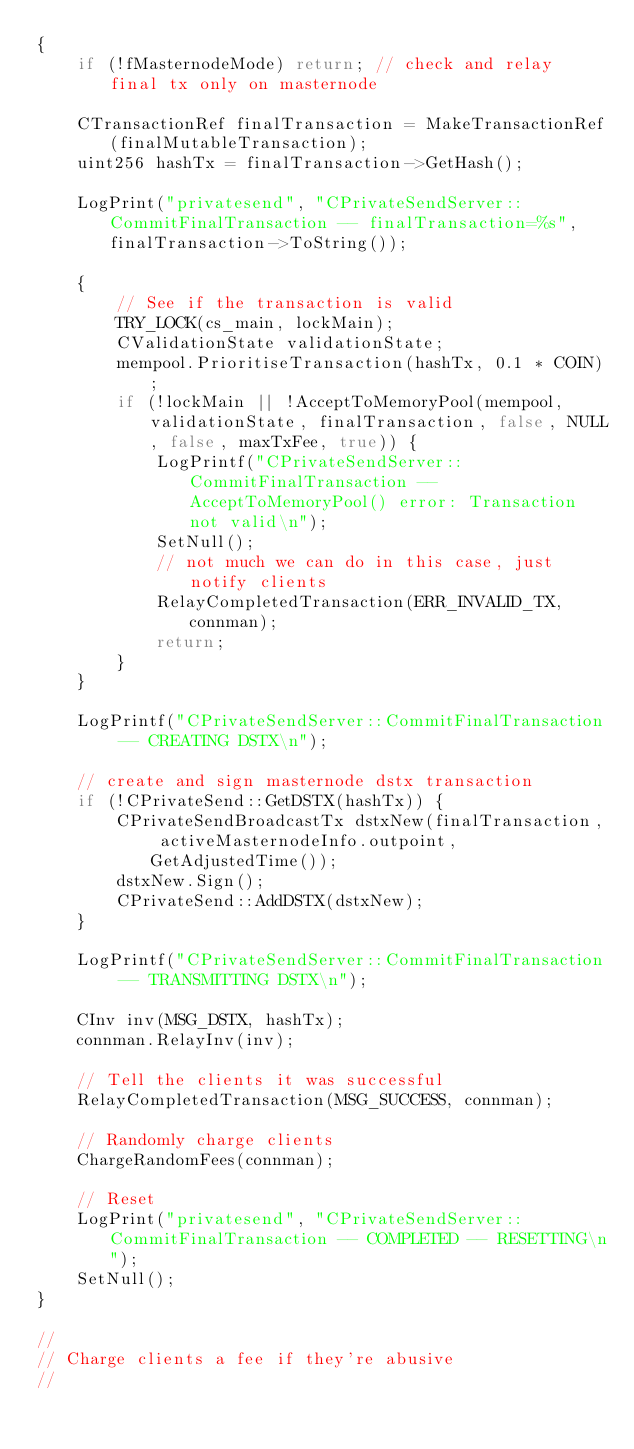Convert code to text. <code><loc_0><loc_0><loc_500><loc_500><_C++_>{
    if (!fMasternodeMode) return; // check and relay final tx only on masternode

    CTransactionRef finalTransaction = MakeTransactionRef(finalMutableTransaction);
    uint256 hashTx = finalTransaction->GetHash();

    LogPrint("privatesend", "CPrivateSendServer::CommitFinalTransaction -- finalTransaction=%s", finalTransaction->ToString());

    {
        // See if the transaction is valid
        TRY_LOCK(cs_main, lockMain);
        CValidationState validationState;
        mempool.PrioritiseTransaction(hashTx, 0.1 * COIN);
        if (!lockMain || !AcceptToMemoryPool(mempool, validationState, finalTransaction, false, NULL, false, maxTxFee, true)) {
            LogPrintf("CPrivateSendServer::CommitFinalTransaction -- AcceptToMemoryPool() error: Transaction not valid\n");
            SetNull();
            // not much we can do in this case, just notify clients
            RelayCompletedTransaction(ERR_INVALID_TX, connman);
            return;
        }
    }

    LogPrintf("CPrivateSendServer::CommitFinalTransaction -- CREATING DSTX\n");

    // create and sign masternode dstx transaction
    if (!CPrivateSend::GetDSTX(hashTx)) {
        CPrivateSendBroadcastTx dstxNew(finalTransaction, activeMasternodeInfo.outpoint, GetAdjustedTime());
        dstxNew.Sign();
        CPrivateSend::AddDSTX(dstxNew);
    }

    LogPrintf("CPrivateSendServer::CommitFinalTransaction -- TRANSMITTING DSTX\n");

    CInv inv(MSG_DSTX, hashTx);
    connman.RelayInv(inv);

    // Tell the clients it was successful
    RelayCompletedTransaction(MSG_SUCCESS, connman);

    // Randomly charge clients
    ChargeRandomFees(connman);

    // Reset
    LogPrint("privatesend", "CPrivateSendServer::CommitFinalTransaction -- COMPLETED -- RESETTING\n");
    SetNull();
}

//
// Charge clients a fee if they're abusive
//</code> 